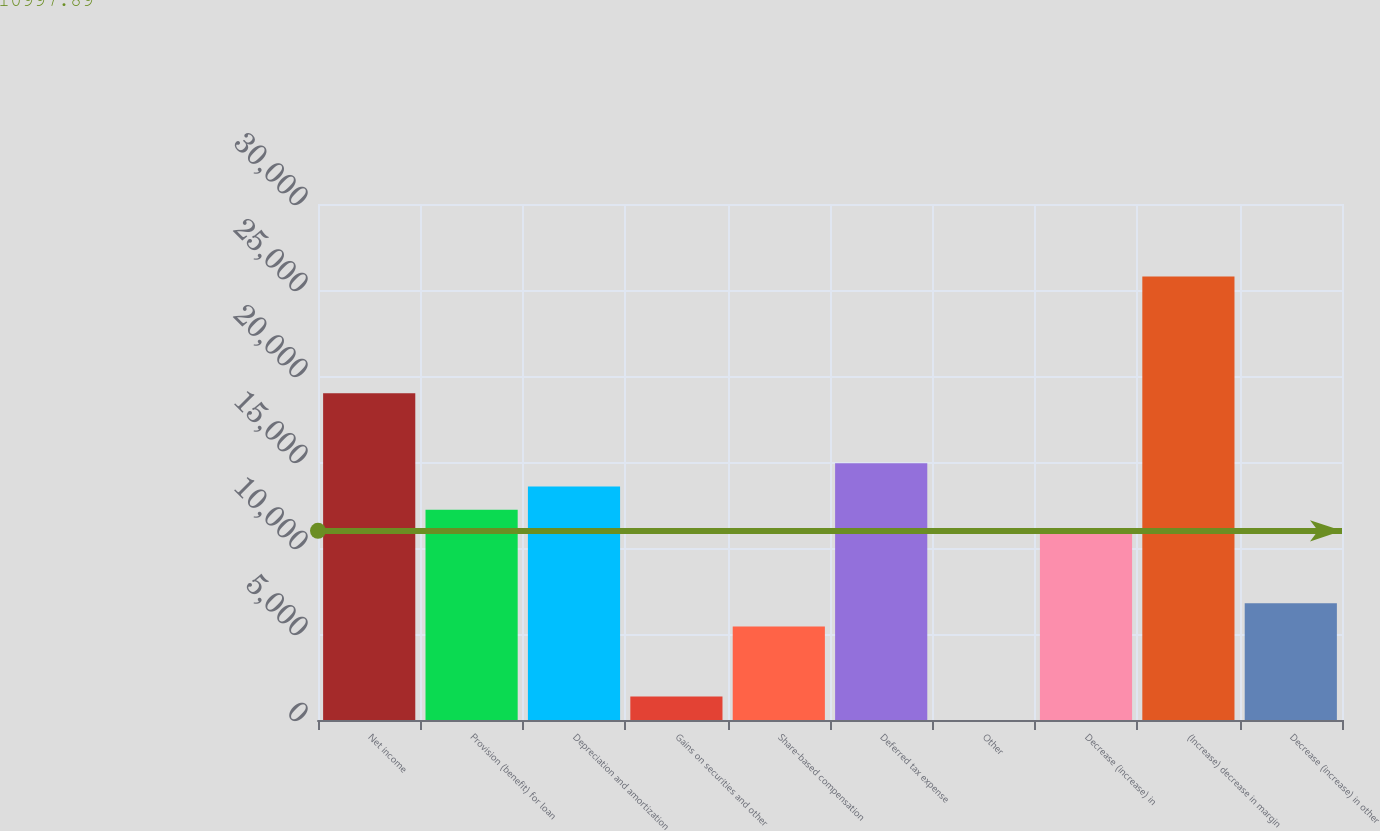<chart> <loc_0><loc_0><loc_500><loc_500><bar_chart><fcel>Net income<fcel>Provision (benefit) for loan<fcel>Depreciation and amortization<fcel>Gains on securities and other<fcel>Share-based compensation<fcel>Deferred tax expense<fcel>Other<fcel>Decrease (increase) in<fcel>(Increase) decrease in margin<fcel>Decrease (increase) in other<nl><fcel>19003.6<fcel>12219.1<fcel>13576<fcel>1363.9<fcel>5434.6<fcel>14932.9<fcel>7<fcel>10862.2<fcel>25788.1<fcel>6791.5<nl></chart> 